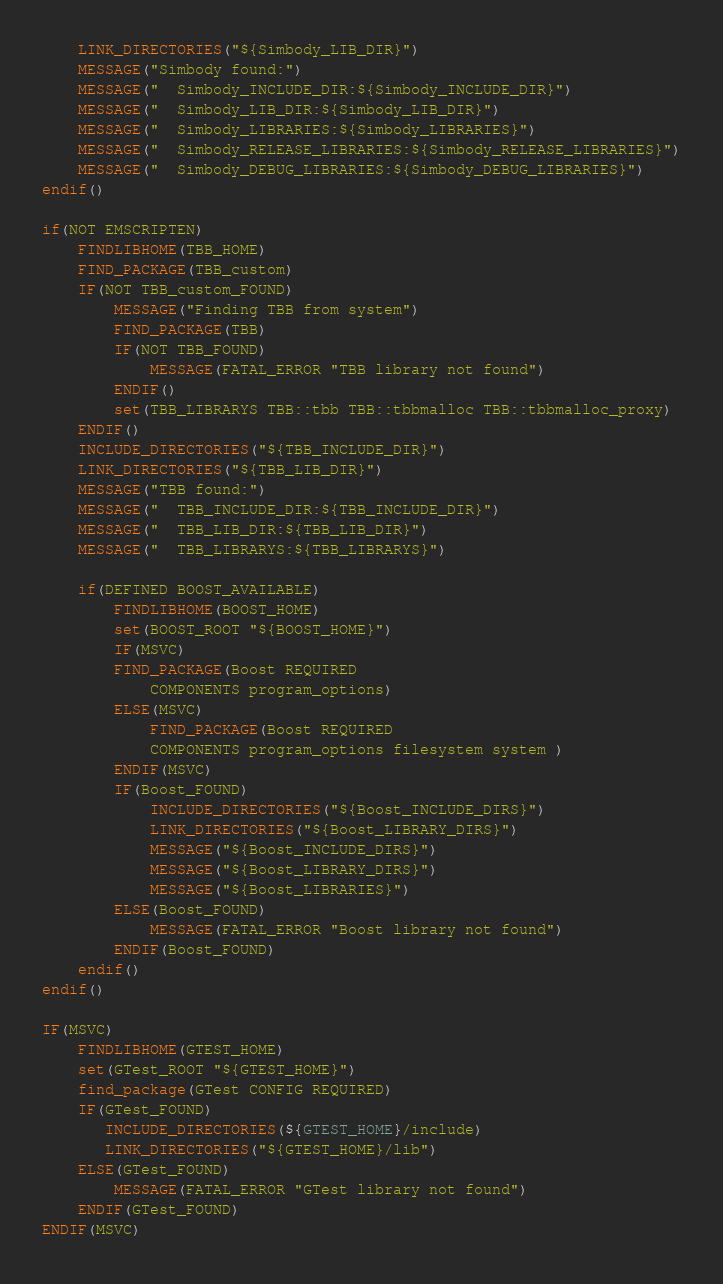<code> <loc_0><loc_0><loc_500><loc_500><_CMake_>    LINK_DIRECTORIES("${Simbody_LIB_DIR}")
    MESSAGE("Simbody found:")
    MESSAGE("  Simbody_INCLUDE_DIR:${Simbody_INCLUDE_DIR}")
    MESSAGE("  Simbody_LIB_DIR:${Simbody_LIB_DIR}")
    MESSAGE("  Simbody_LIBRARIES:${Simbody_LIBRARIES}")
    MESSAGE("  Simbody_RELEASE_LIBRARIES:${Simbody_RELEASE_LIBRARIES}")
    MESSAGE("  Simbody_DEBUG_LIBRARIES:${Simbody_DEBUG_LIBRARIES}")
endif()

if(NOT EMSCRIPTEN)
    FINDLIBHOME(TBB_HOME)
    FIND_PACKAGE(TBB_custom)
    IF(NOT TBB_custom_FOUND)
        MESSAGE("Finding TBB from system")
        FIND_PACKAGE(TBB)
        IF(NOT TBB_FOUND)
            MESSAGE(FATAL_ERROR "TBB library not found")
        ENDIF()
        set(TBB_LIBRARYS TBB::tbb TBB::tbbmalloc TBB::tbbmalloc_proxy)
    ENDIF()
    INCLUDE_DIRECTORIES("${TBB_INCLUDE_DIR}")
    LINK_DIRECTORIES("${TBB_LIB_DIR}")
    MESSAGE("TBB found:")
    MESSAGE("  TBB_INCLUDE_DIR:${TBB_INCLUDE_DIR}")
    MESSAGE("  TBB_LIB_DIR:${TBB_LIB_DIR}")
    MESSAGE("  TBB_LIBRARYS:${TBB_LIBRARYS}")

    if(DEFINED BOOST_AVAILABLE)
        FINDLIBHOME(BOOST_HOME)
        set(BOOST_ROOT "${BOOST_HOME}")
        IF(MSVC)
        FIND_PACKAGE(Boost REQUIRED 
            COMPONENTS program_options)
        ELSE(MSVC)
            FIND_PACKAGE(Boost REQUIRED 
            COMPONENTS program_options filesystem system )
        ENDIF(MSVC)
        IF(Boost_FOUND)
            INCLUDE_DIRECTORIES("${Boost_INCLUDE_DIRS}")
            LINK_DIRECTORIES("${Boost_LIBRARY_DIRS}")
            MESSAGE("${Boost_INCLUDE_DIRS}")
            MESSAGE("${Boost_LIBRARY_DIRS}")
            MESSAGE("${Boost_LIBRARIES}")
        ELSE(Boost_FOUND)
            MESSAGE(FATAL_ERROR "Boost library not found")
        ENDIF(Boost_FOUND)
    endif()
endif()

IF(MSVC)
    FINDLIBHOME(GTEST_HOME)
    set(GTest_ROOT "${GTEST_HOME}") 
    find_package(GTest CONFIG REQUIRED)
    IF(GTest_FOUND)
       INCLUDE_DIRECTORIES(${GTEST_HOME}/include)
       LINK_DIRECTORIES("${GTEST_HOME}/lib")
    ELSE(GTest_FOUND)
        MESSAGE(FATAL_ERROR "GTest library not found")
    ENDIF(GTest_FOUND)
ENDIF(MSVC)
</code> 